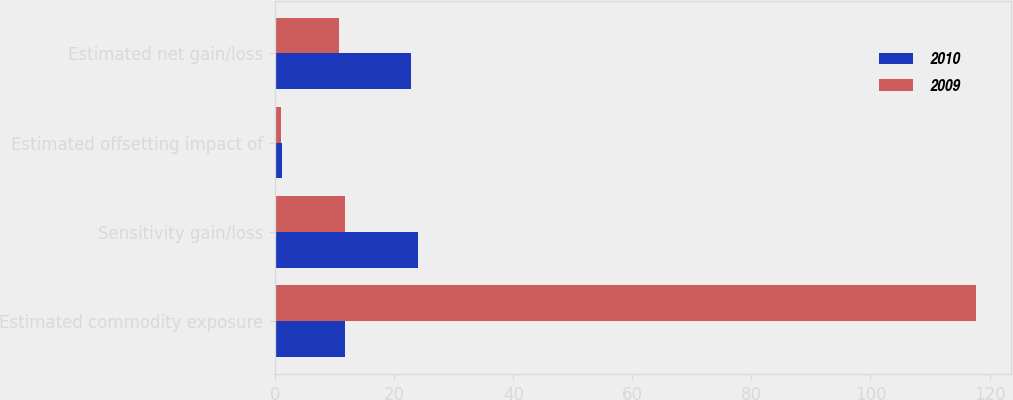Convert chart. <chart><loc_0><loc_0><loc_500><loc_500><stacked_bar_chart><ecel><fcel>Estimated commodity exposure<fcel>Sensitivity gain/loss<fcel>Estimated offsetting impact of<fcel>Estimated net gain/loss<nl><fcel>2010<fcel>11.8<fcel>24<fcel>1.2<fcel>22.8<nl><fcel>2009<fcel>117.8<fcel>11.8<fcel>1<fcel>10.8<nl></chart> 